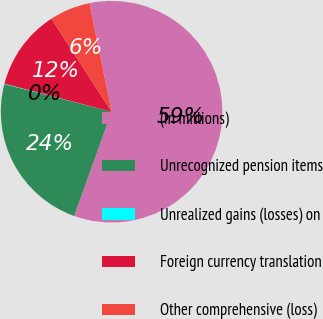<chart> <loc_0><loc_0><loc_500><loc_500><pie_chart><fcel>(In millions)<fcel>Unrecognized pension items<fcel>Unrealized gains (losses) on<fcel>Foreign currency translation<fcel>Other comprehensive (loss)<nl><fcel>58.69%<fcel>23.52%<fcel>0.07%<fcel>11.79%<fcel>5.93%<nl></chart> 